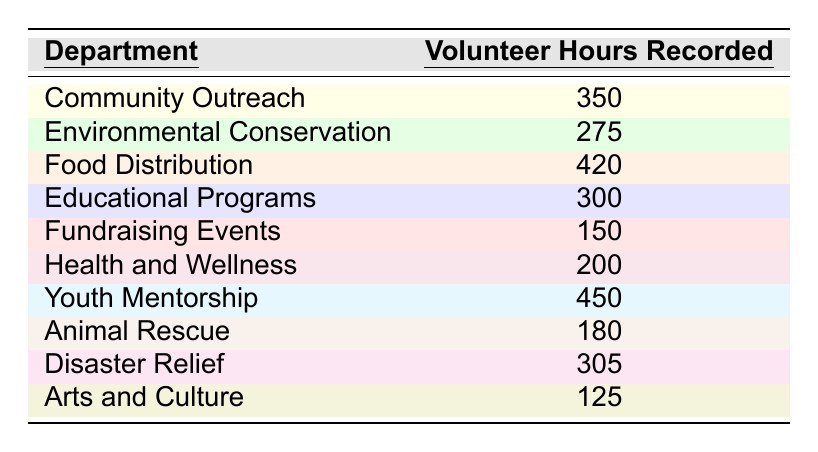What department recorded the most volunteer hours? The table shows the recorded volunteer hours for each department. Upon inspection, the department with the highest recorded hours is Youth Mentorship, which recorded 450 hours.
Answer: Youth Mentorship How many total volunteer hours were recorded across all departments? To find the total, we add the volunteer hours recorded by each department: 350 + 275 + 420 + 300 + 150 + 200 + 450 + 180 + 305 + 125 = 2855.
Answer: 2855 Which department recorded the least number of volunteer hours? Looking at the table, Fundraising Events recorded the fewest hours with a total of 150.
Answer: Fundraising Events What is the average number of volunteer hours recorded per department? There are 10 departments. We sum the volunteer hours (2855) and divide by 10: 2855 / 10 = 285.5.
Answer: 285.5 How many more hours did Food Distribution record than Health and Wellness? Food Distribution recorded 420 hours, while Health and Wellness recorded 200 hours. The difference is 420 - 200 = 220 hours.
Answer: 220 Is it true that Environmental Conservation recorded more volunteer hours than Animal Rescue? Environmental Conservation recorded 275 hours and Animal Rescue recorded 180 hours. Since 275 is greater than 180, the statement is true.
Answer: Yes What percentage of the total volunteer hours were recorded by Youth Mentorship? Youth Mentorship recorded 450 hours. To find the percentage of total hours, calculate (450 / 2855) * 100 ≈ 15.73%.
Answer: 15.73% Which two departments together have volunteer hours that exceed 600? We check combinations of two departments. Community Outreach (350) + Food Distribution (420) = 770; Youth Mentorship (450) + Health and Wellness (200) = 650. Both pairs exceed 600 hours.
Answer: Yes Which department has the second highest recorded volunteer hours? After identifying Youth Mentorship with the highest hours (450), we look for the next highest, which is Food Distribution at 420 hours.
Answer: Food Distribution How many departments recorded more than 300 volunteer hours? The departments with hours above 300 are Community Outreach (350), Food Distribution (420), Educational Programs (300), Youth Mentorship (450), and Disaster Relief (305), totaling five departments.
Answer: 5 